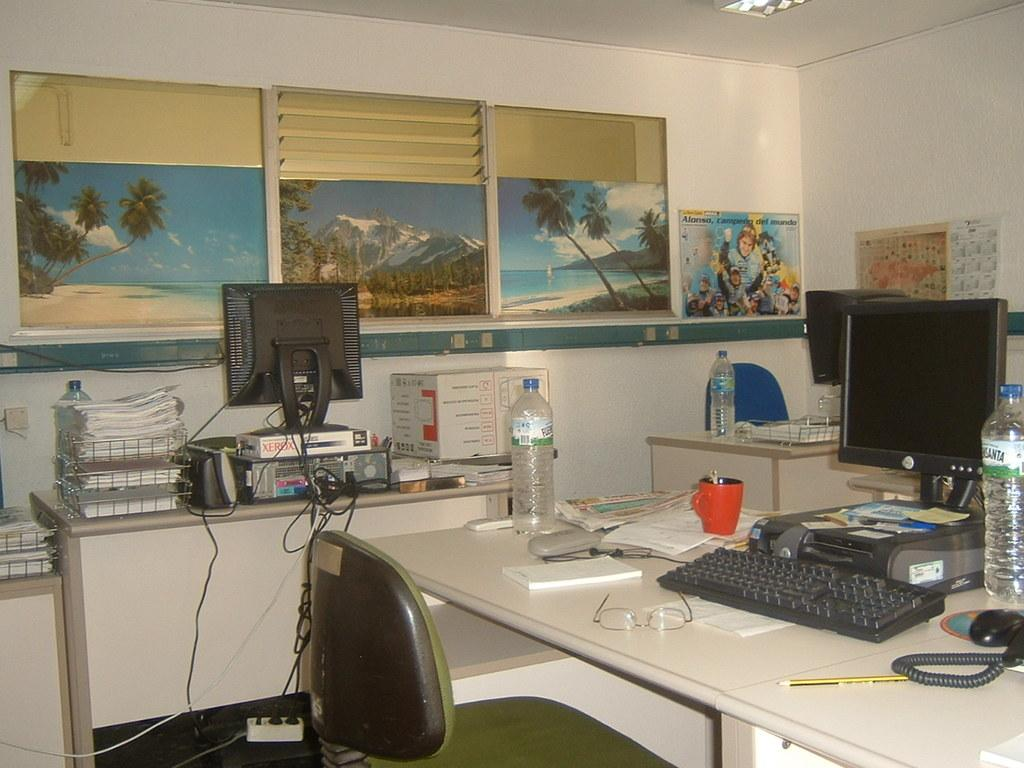Provide a one-sentence caption for the provided image. A messy office shows a desk scattered with objects and a Dell computer. 